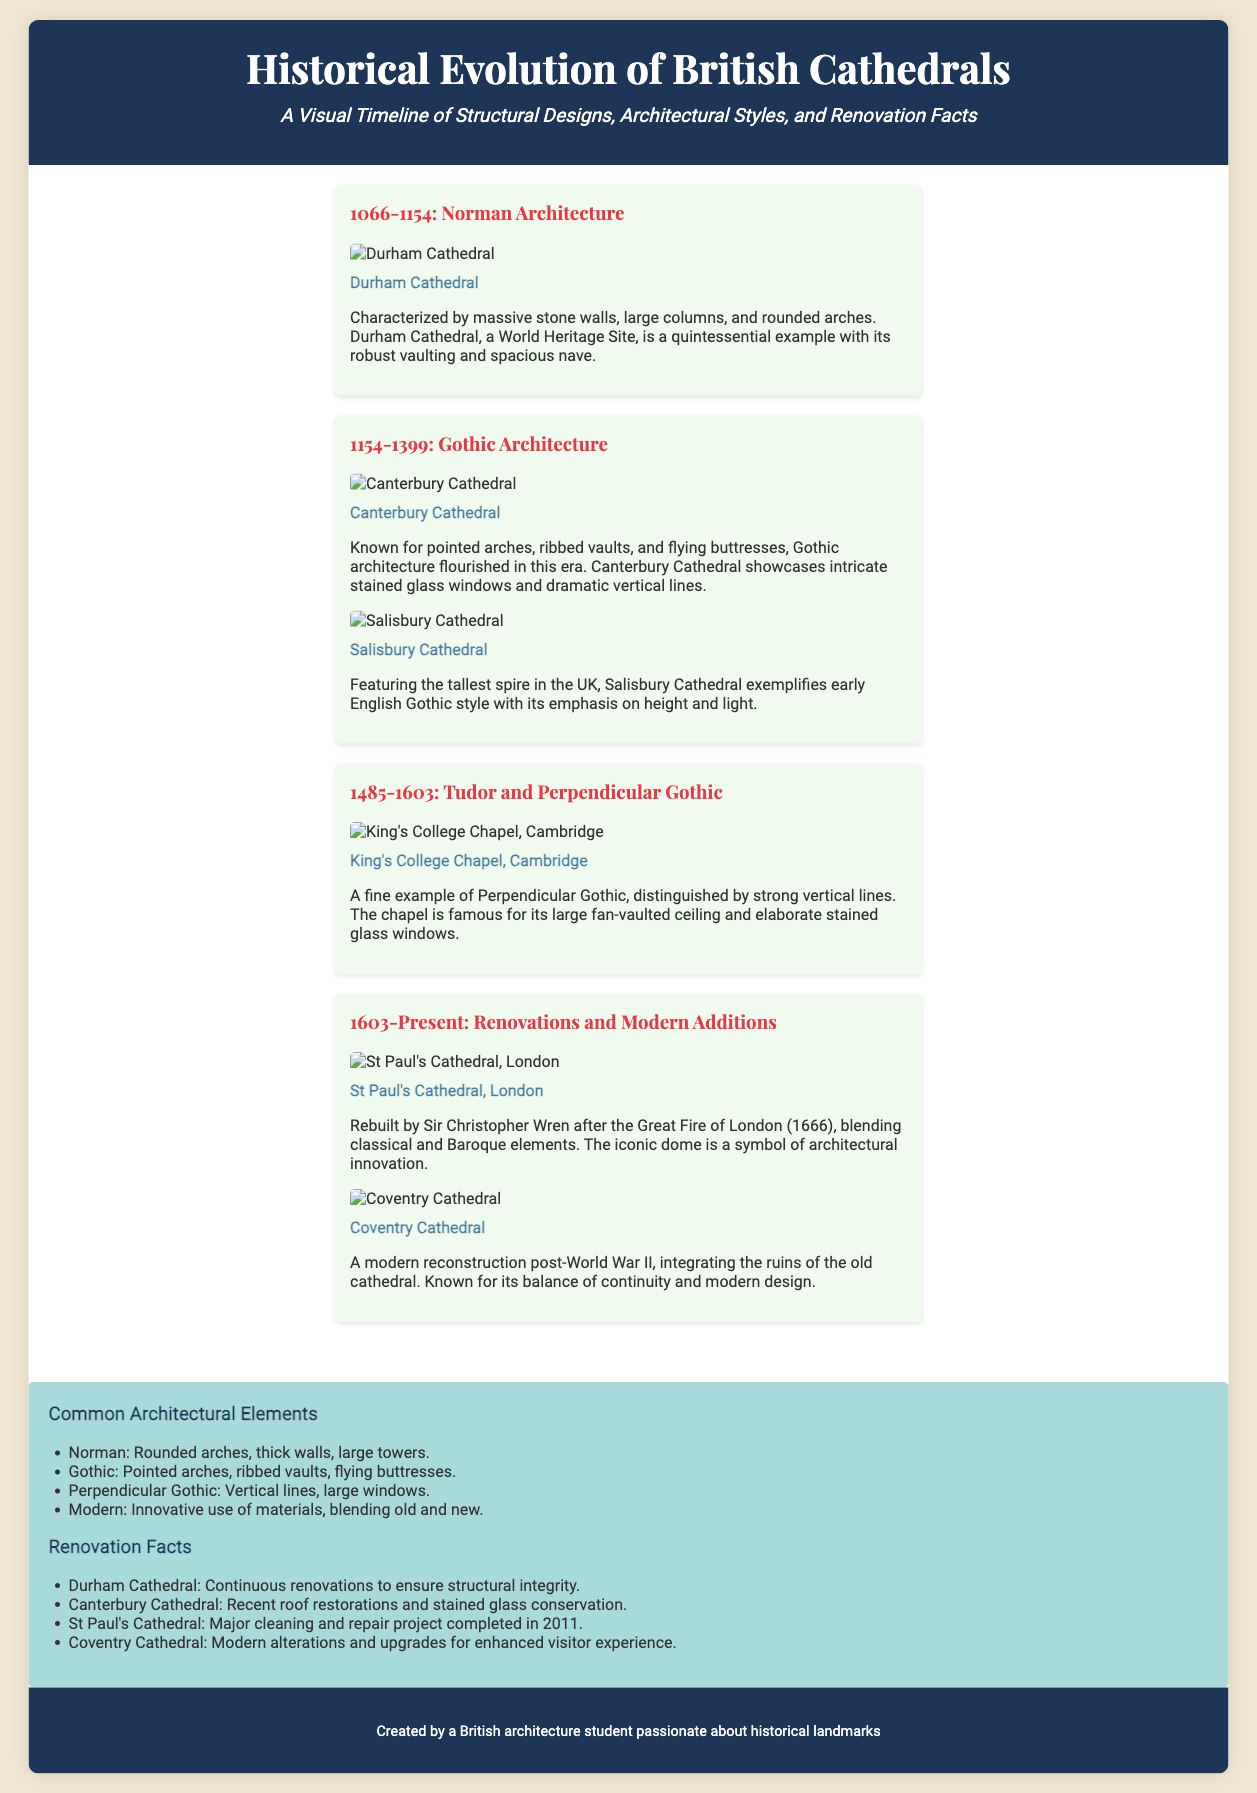What is the name of the cathedral that exemplifies Norman architecture? Durham Cathedral is highlighted as a quintessential example of Norman architecture in the document.
Answer: Durham Cathedral What architectural style is Canterbury Cathedral known for? Canterbury Cathedral is known for Gothic architecture, characterized by pointed arches and ribbed vaults.
Answer: Gothic Architecture Which cathedral features the tallest spire in the UK? Salisbury Cathedral is mentioned as having the tallest spire in the UK, exemplifying early English Gothic style.
Answer: Salisbury Cathedral What important renovation occurred at St Paul's Cathedral in 2011? The document states that a major cleaning and repair project was completed at St Paul's Cathedral in 2011.
Answer: Cleaning and repair project In which era was King's College Chapel, Cambridge constructed? King's College Chapel, Cambridge is classified under the Tudor and Perpendicular Gothic era, which spans from 1485 to 1603.
Answer: Tudor and Perpendicular Gothic What is a common element of Gothic architecture mentioned? The common architectural element of Gothic architecture includes pointed arches, ribbed vaults, and flying buttresses.
Answer: Pointed arches Which cathedral was reconstructed after World War II? Coventry Cathedral is noted for its modern reconstruction post-World War II, integrating the ruins of the old cathedral.
Answer: Coventry Cathedral What characterizes the architectural style of the era 1603-Present? The era 1603-Present is characterized by renovations and modern additions to existing structures.
Answer: Renovations and modern additions What do the featured-data sections discuss? The featured-data sections discuss common architectural elements and renovation facts about the featured cathedrals.
Answer: Common architectural elements and renovation facts 